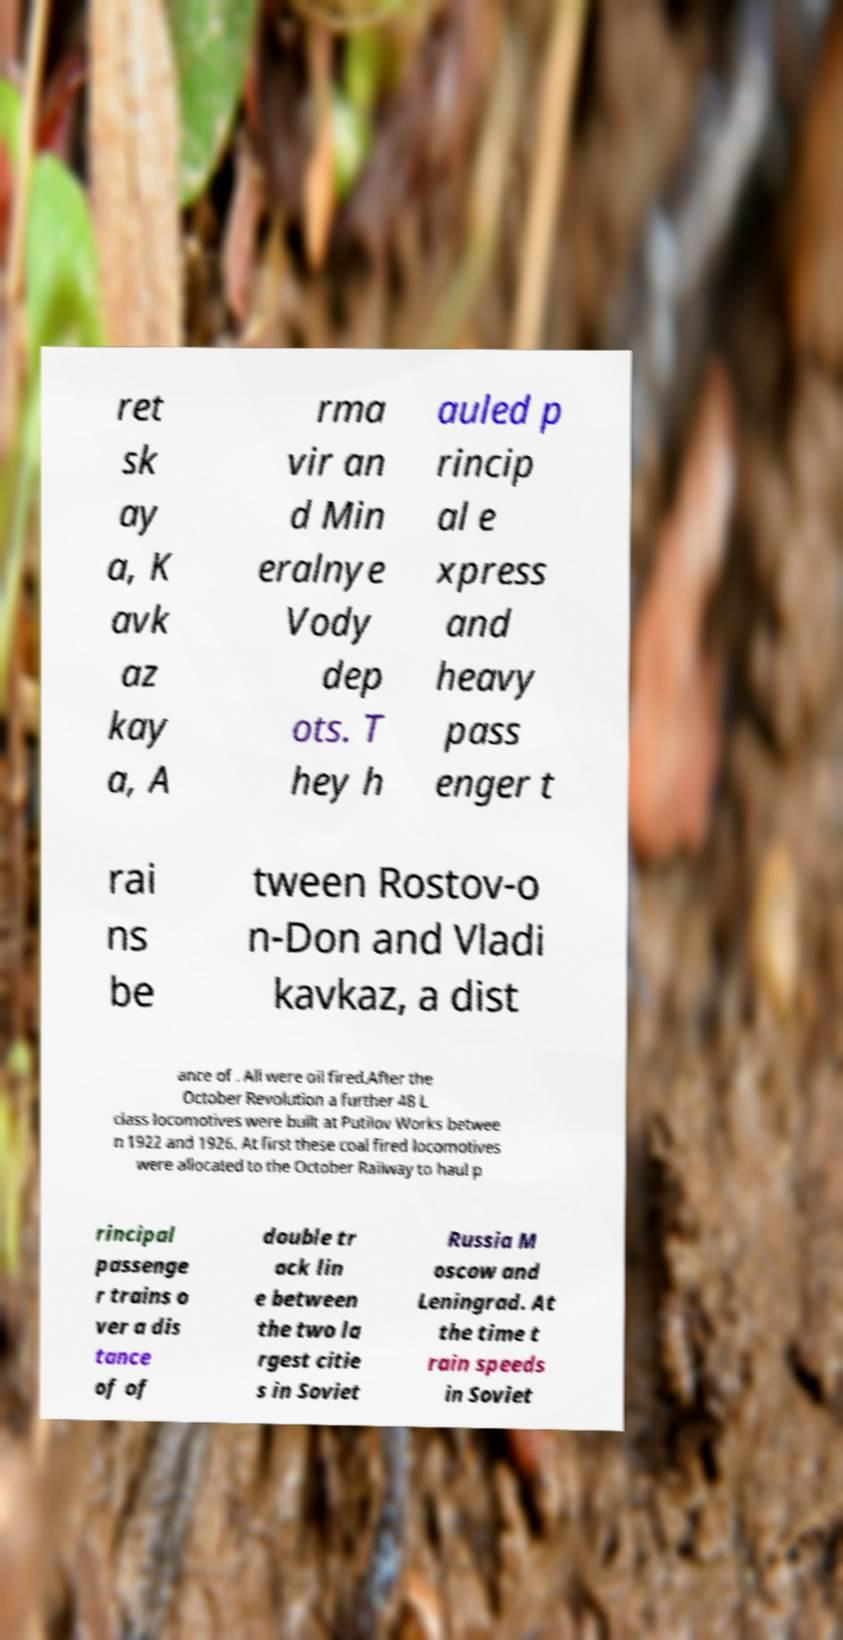Could you extract and type out the text from this image? ret sk ay a, K avk az kay a, A rma vir an d Min eralnye Vody dep ots. T hey h auled p rincip al e xpress and heavy pass enger t rai ns be tween Rostov-o n-Don and Vladi kavkaz, a dist ance of . All were oil fired.After the October Revolution a further 48 L class locomotives were built at Putilov Works betwee n 1922 and 1926. At first these coal fired locomotives were allocated to the October Railway to haul p rincipal passenge r trains o ver a dis tance of of double tr ack lin e between the two la rgest citie s in Soviet Russia M oscow and Leningrad. At the time t rain speeds in Soviet 